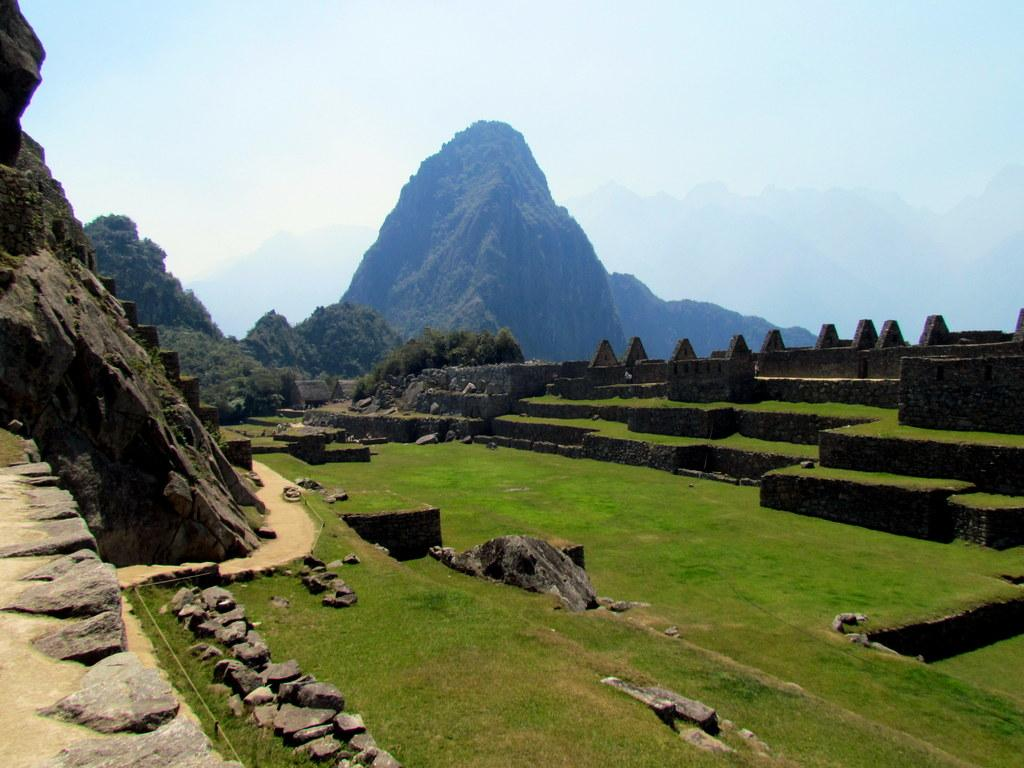What type of vegetation is present on the ground in the front of the image? There is: There is grass on the ground in the front of the image. What can be seen in the background of the image? In the background of the image, there are stones, trees, and mountains. Can you describe the landscape in the image? The landscape in the image features grass on the ground in the front, and in the background, there are stones, trees, and mountains. What advice is being given in the image? There is no indication in the image that any advice is being given. What type of organization is depicted in the image? There is no organization depicted in the image; it features a landscape with grass, stones, trees, and mountains. 